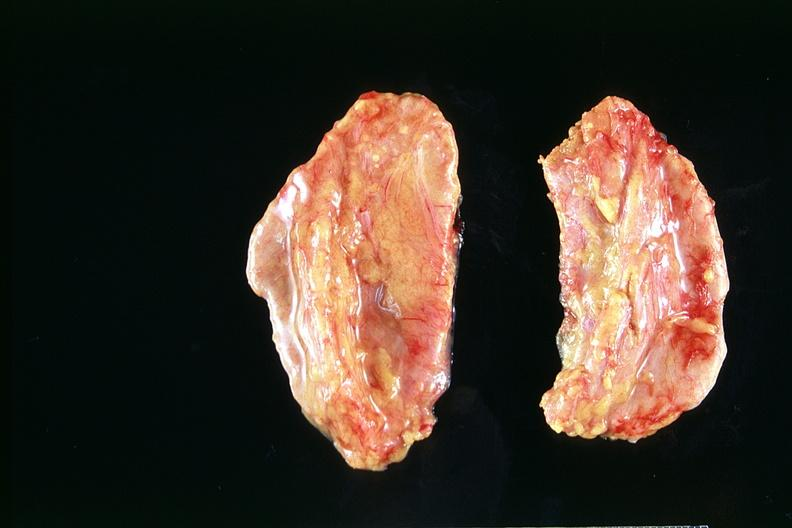what is present?
Answer the question using a single word or phrase. Endocrine 